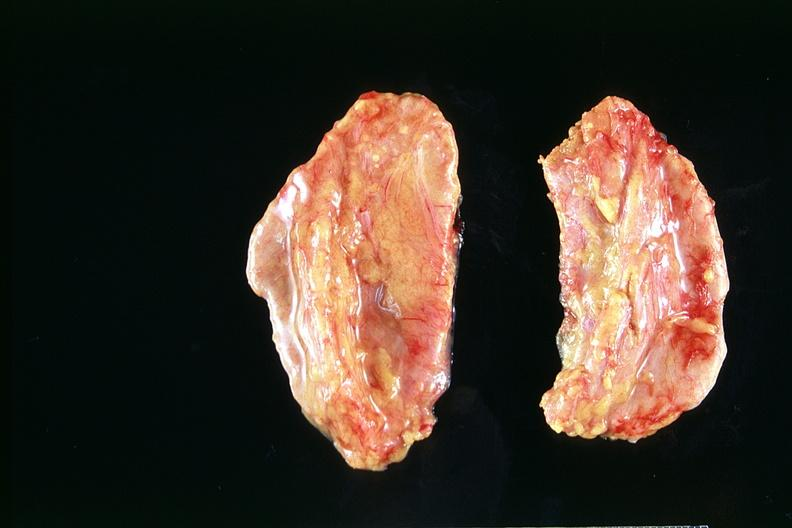what is present?
Answer the question using a single word or phrase. Endocrine 